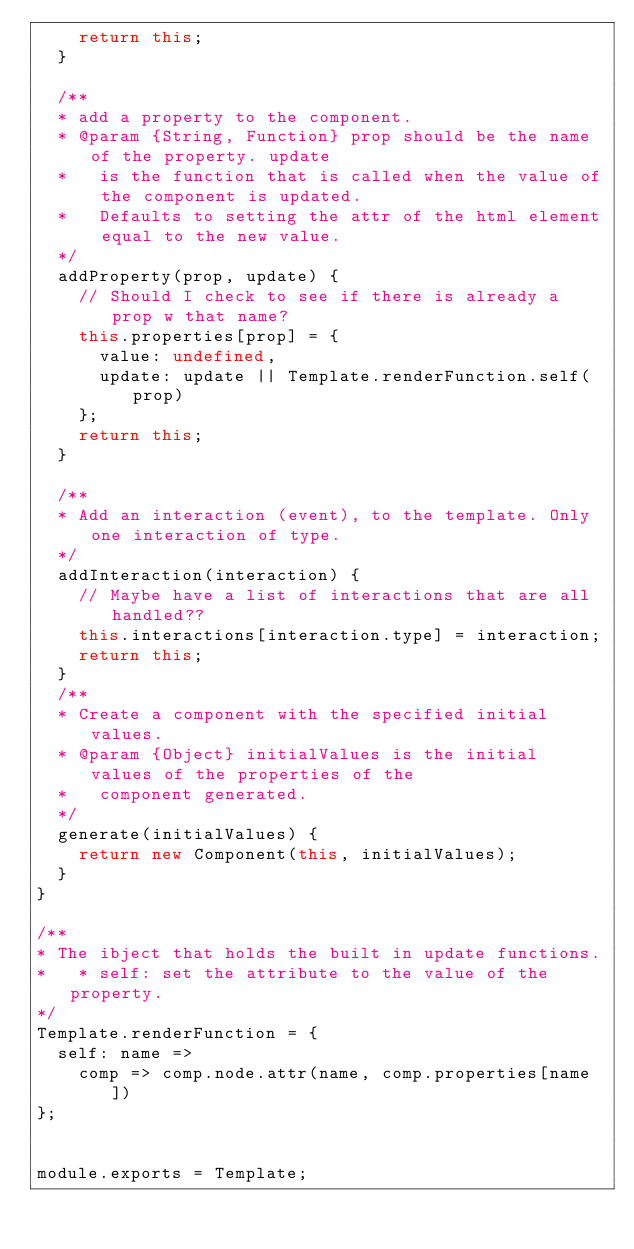Convert code to text. <code><loc_0><loc_0><loc_500><loc_500><_JavaScript_>    return this;
  }

  /**
  * add a property to the component.
  * @param {String, Function} prop should be the name of the property. update
  *   is the function that is called when the value of the component is updated.
  *   Defaults to setting the attr of the html element equal to the new value.
  */
  addProperty(prop, update) {
    // Should I check to see if there is already a prop w that name?
    this.properties[prop] = {
      value: undefined,
      update: update || Template.renderFunction.self(prop)
    };
    return this;
  }

  /**
  * Add an interaction (event), to the template. Only one interaction of type.
  */
  addInteraction(interaction) {
    // Maybe have a list of interactions that are all handled??
    this.interactions[interaction.type] = interaction;
    return this;
  }
  /**
  * Create a component with the specified initial values.
  * @param {Object} initialValues is the initial values of the properties of the
  *   component generated.
  */
  generate(initialValues) {
    return new Component(this, initialValues);
  }
}

/**
* The ibject that holds the built in update functions.
*   * self: set the attribute to the value of the property.
*/
Template.renderFunction = {
  self: name =>
    comp => comp.node.attr(name, comp.properties[name])
};


module.exports = Template;
</code> 